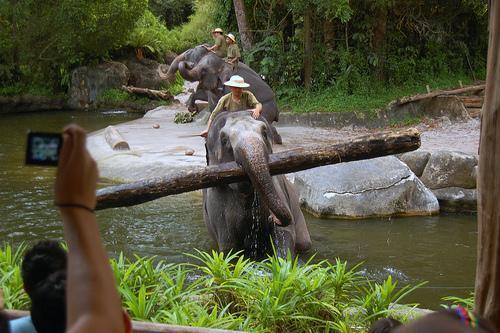How many elephant are here?
Give a very brief answer. 3. 